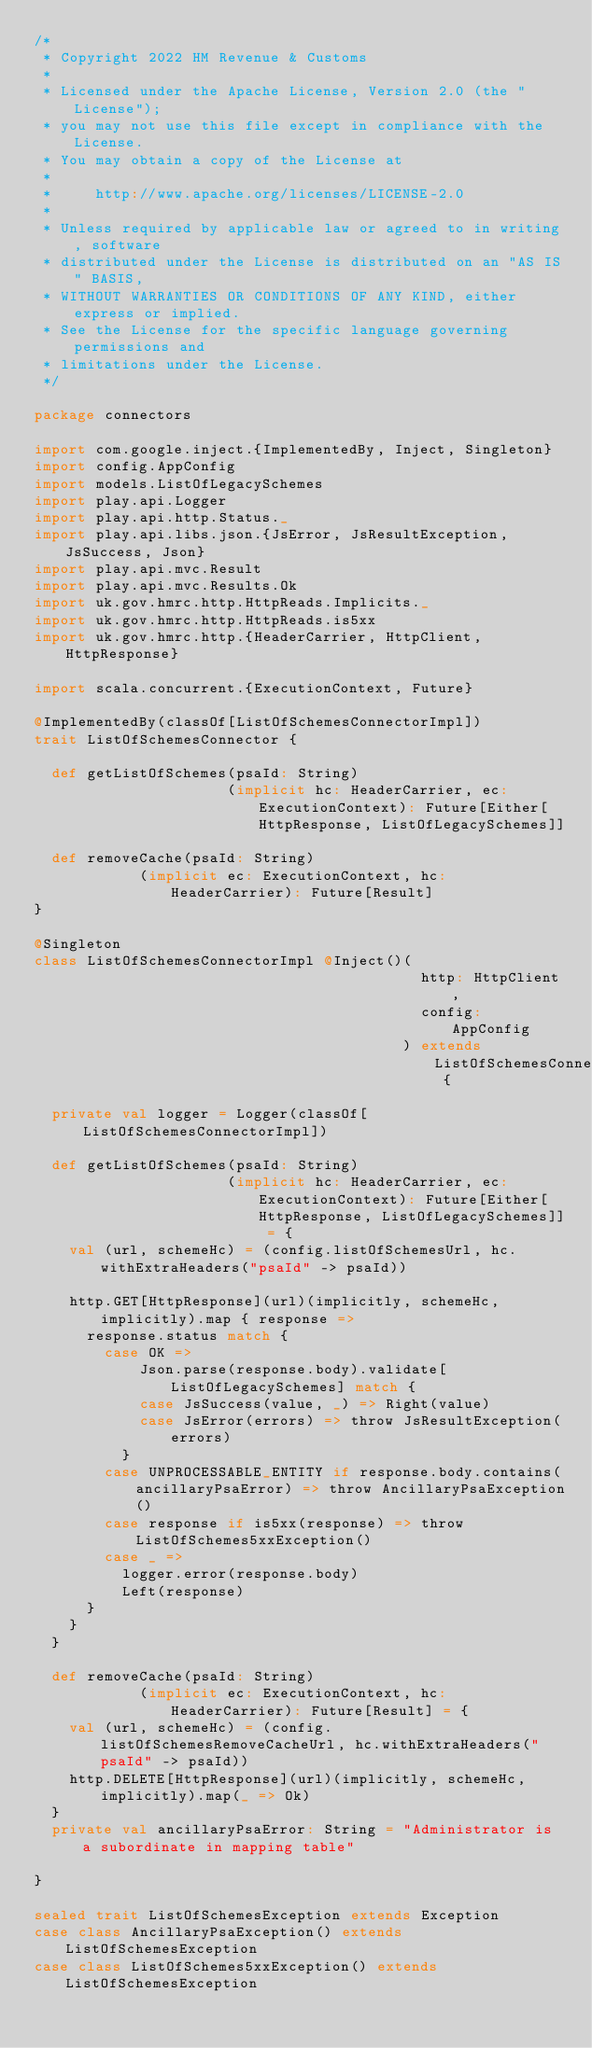<code> <loc_0><loc_0><loc_500><loc_500><_Scala_>/*
 * Copyright 2022 HM Revenue & Customs
 *
 * Licensed under the Apache License, Version 2.0 (the "License");
 * you may not use this file except in compliance with the License.
 * You may obtain a copy of the License at
 *
 *     http://www.apache.org/licenses/LICENSE-2.0
 *
 * Unless required by applicable law or agreed to in writing, software
 * distributed under the License is distributed on an "AS IS" BASIS,
 * WITHOUT WARRANTIES OR CONDITIONS OF ANY KIND, either express or implied.
 * See the License for the specific language governing permissions and
 * limitations under the License.
 */

package connectors

import com.google.inject.{ImplementedBy, Inject, Singleton}
import config.AppConfig
import models.ListOfLegacySchemes
import play.api.Logger
import play.api.http.Status._
import play.api.libs.json.{JsError, JsResultException, JsSuccess, Json}
import play.api.mvc.Result
import play.api.mvc.Results.Ok
import uk.gov.hmrc.http.HttpReads.Implicits._
import uk.gov.hmrc.http.HttpReads.is5xx
import uk.gov.hmrc.http.{HeaderCarrier, HttpClient, HttpResponse}

import scala.concurrent.{ExecutionContext, Future}

@ImplementedBy(classOf[ListOfSchemesConnectorImpl])
trait ListOfSchemesConnector {

  def getListOfSchemes(psaId: String)
                      (implicit hc: HeaderCarrier, ec: ExecutionContext): Future[Either[HttpResponse, ListOfLegacySchemes]]

  def removeCache(psaId: String)
            (implicit ec: ExecutionContext, hc: HeaderCarrier): Future[Result]
}

@Singleton
class ListOfSchemesConnectorImpl @Inject()(
                                            http: HttpClient,
                                            config: AppConfig
                                          ) extends ListOfSchemesConnector {

  private val logger = Logger(classOf[ListOfSchemesConnectorImpl])

  def getListOfSchemes(psaId: String)
                      (implicit hc: HeaderCarrier, ec: ExecutionContext): Future[Either[HttpResponse, ListOfLegacySchemes]] = {
    val (url, schemeHc) = (config.listOfSchemesUrl, hc.withExtraHeaders("psaId" -> psaId))

    http.GET[HttpResponse](url)(implicitly, schemeHc, implicitly).map { response =>
      response.status match {
        case OK =>
            Json.parse(response.body).validate[ListOfLegacySchemes] match {
            case JsSuccess(value, _) => Right(value)
            case JsError(errors) => throw JsResultException(errors)
          }
        case UNPROCESSABLE_ENTITY if response.body.contains(ancillaryPsaError) => throw AncillaryPsaException()
        case response if is5xx(response) => throw ListOfSchemes5xxException()
        case _ =>
          logger.error(response.body)
          Left(response)
      }
    }
  }

  def removeCache(psaId: String)
            (implicit ec: ExecutionContext, hc: HeaderCarrier): Future[Result] = {
    val (url, schemeHc) = (config.listOfSchemesRemoveCacheUrl, hc.withExtraHeaders("psaId" -> psaId))
    http.DELETE[HttpResponse](url)(implicitly, schemeHc, implicitly).map(_ => Ok)
  }
  private val ancillaryPsaError: String = "Administrator is a subordinate in mapping table"

}

sealed trait ListOfSchemesException extends Exception
case class AncillaryPsaException() extends ListOfSchemesException
case class ListOfSchemes5xxException() extends ListOfSchemesException

</code> 